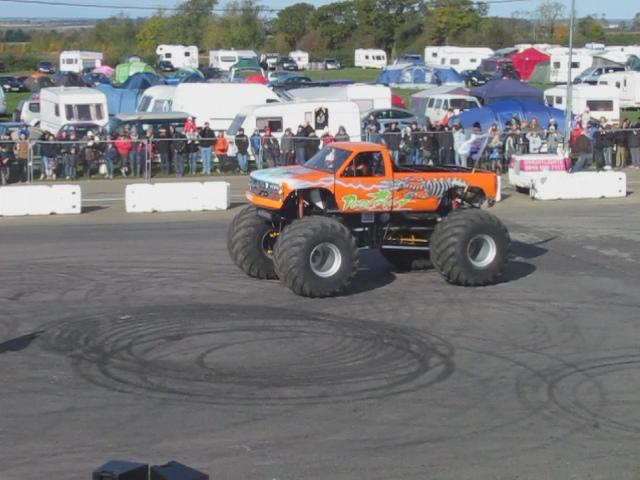What are the circular patterns on the ground? Please explain your reasoning. tire tracks. The marks on the ground happen when something with rubber tires drives really fast in a circle and then brakes hard. 